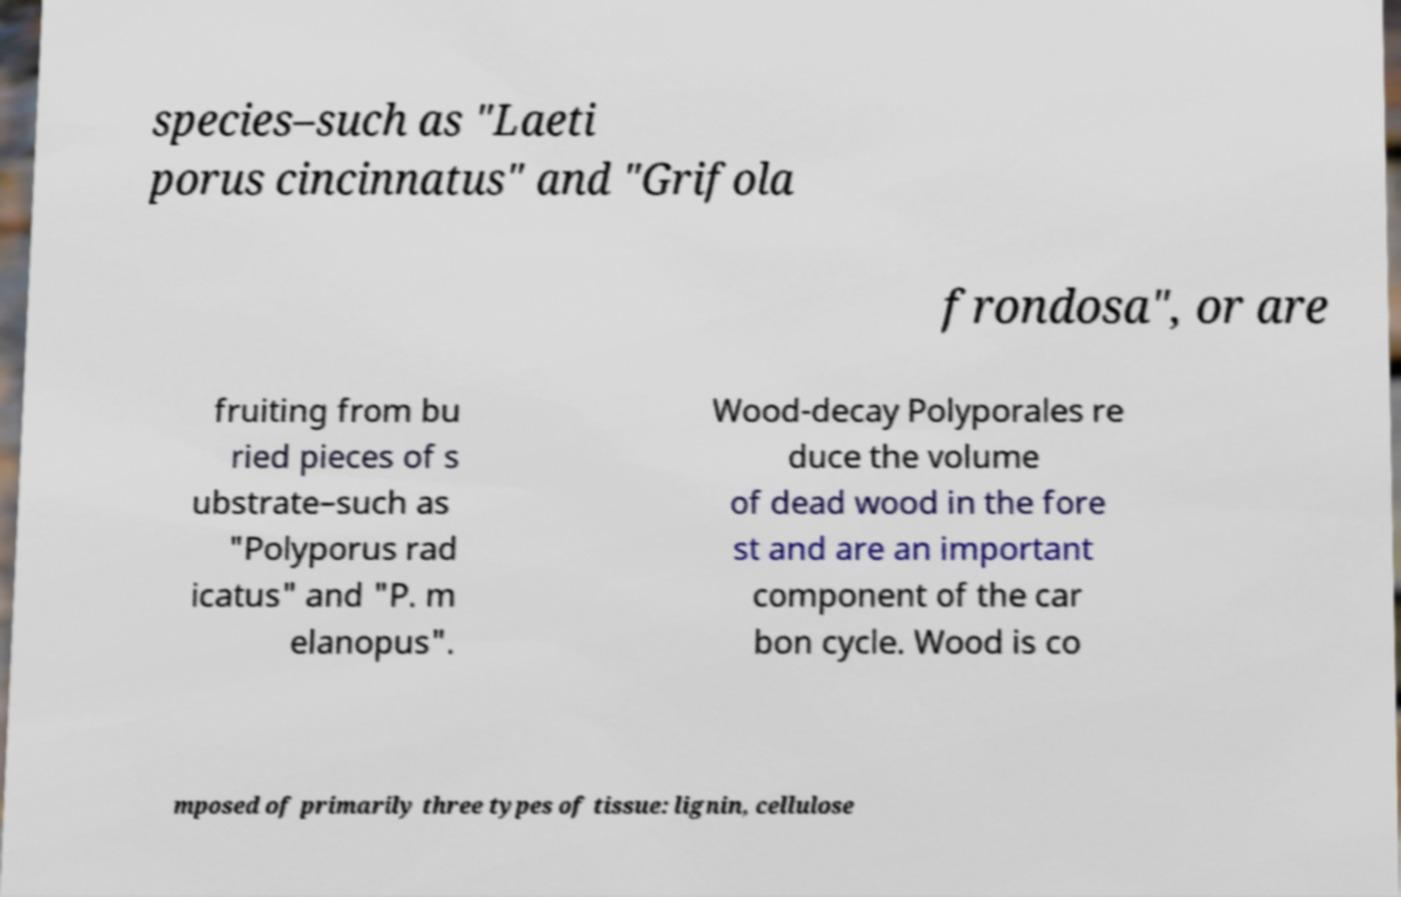Could you assist in decoding the text presented in this image and type it out clearly? species–such as "Laeti porus cincinnatus" and "Grifola frondosa", or are fruiting from bu ried pieces of s ubstrate–such as "Polyporus rad icatus" and "P. m elanopus". Wood-decay Polyporales re duce the volume of dead wood in the fore st and are an important component of the car bon cycle. Wood is co mposed of primarily three types of tissue: lignin, cellulose 